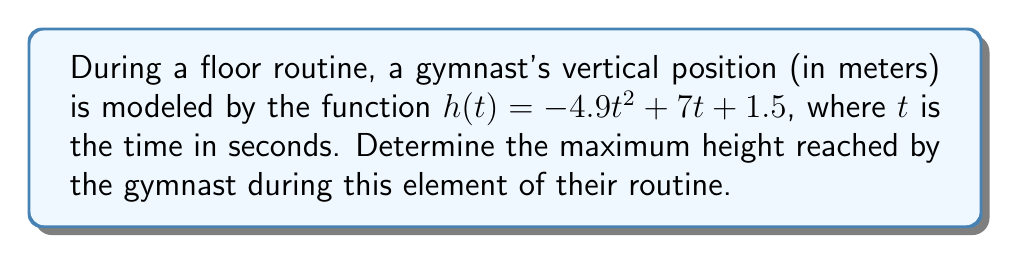What is the answer to this math problem? To find the maximum height, we need to follow these steps:

1) The maximum height occurs at the vertex of the parabola described by $h(t)$. We can find this by using the vertex formula or by finding where the derivative equals zero.

2) Let's use the derivative method:
   
   $h'(t) = -9.8t + 7$

3) Set $h'(t) = 0$ and solve for $t$:
   
   $-9.8t + 7 = 0$
   $-9.8t = -7$
   $t = \frac{7}{9.8} \approx 0.714$ seconds

4) This $t$ value gives us the time at which the maximum height is reached. To find the actual maximum height, we substitute this $t$ value back into our original function:

   $h(0.714) = -4.9(0.714)^2 + 7(0.714) + 1.5$
              $\approx -2.5 + 5 + 1.5$
              $\approx 4$ meters

Therefore, the maximum height reached by the gymnast is approximately 4 meters.
Answer: 4 meters 